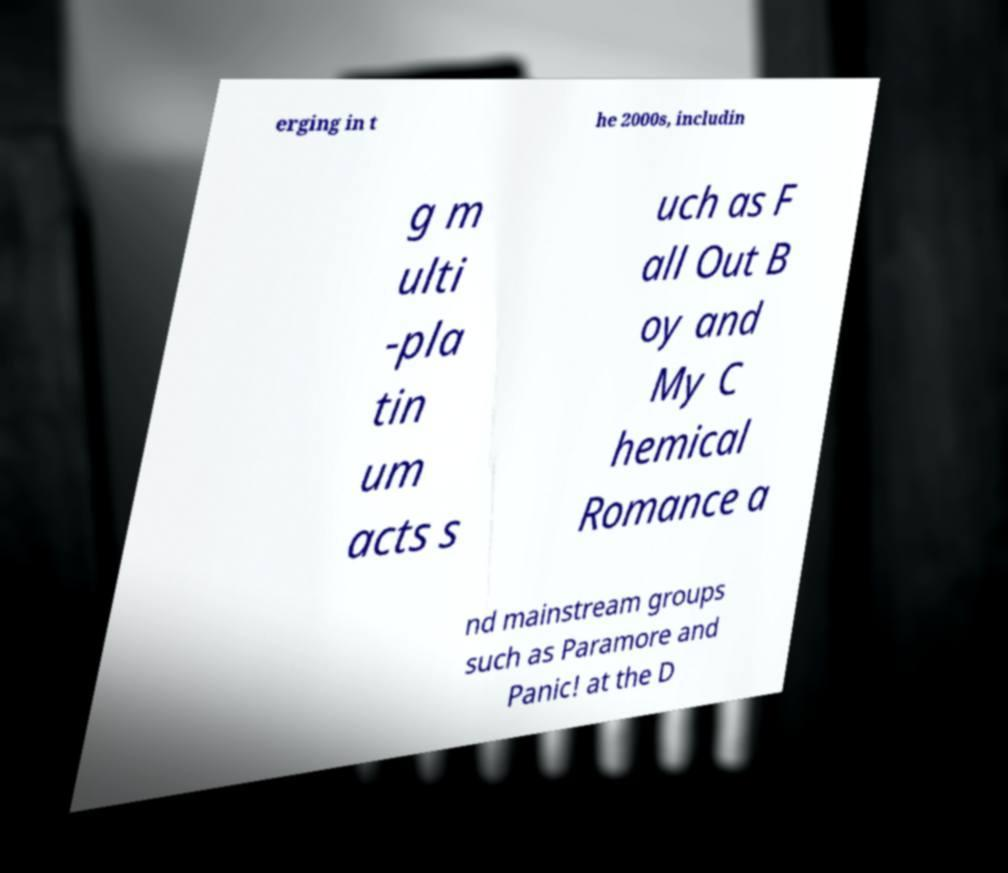Could you assist in decoding the text presented in this image and type it out clearly? erging in t he 2000s, includin g m ulti -pla tin um acts s uch as F all Out B oy and My C hemical Romance a nd mainstream groups such as Paramore and Panic! at the D 